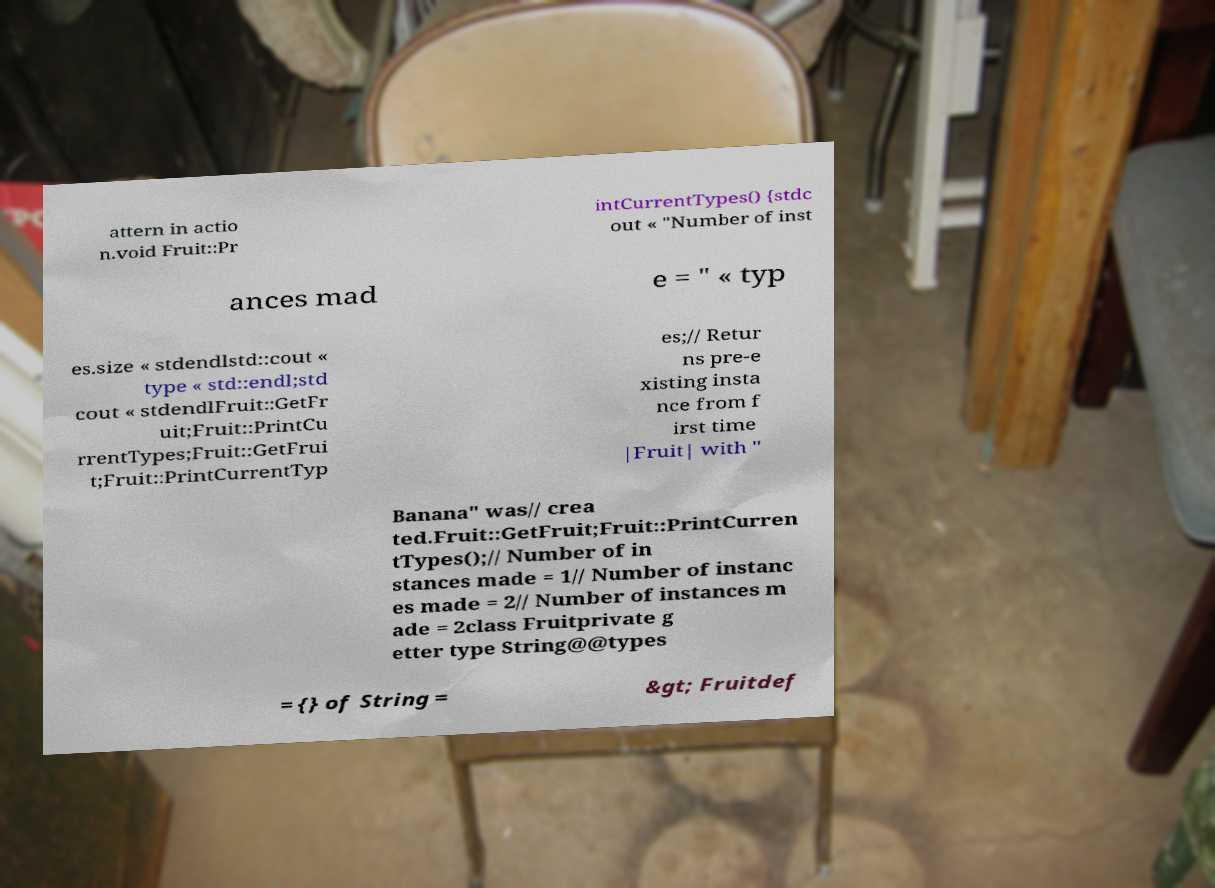There's text embedded in this image that I need extracted. Can you transcribe it verbatim? attern in actio n.void Fruit::Pr intCurrentTypes() {stdc out « "Number of inst ances mad e = " « typ es.size « stdendlstd::cout « type « std::endl;std cout « stdendlFruit::GetFr uit;Fruit::PrintCu rrentTypes;Fruit::GetFrui t;Fruit::PrintCurrentTyp es;// Retur ns pre-e xisting insta nce from f irst time |Fruit| with " Banana" was// crea ted.Fruit::GetFruit;Fruit::PrintCurren tTypes();// Number of in stances made = 1// Number of instanc es made = 2// Number of instances m ade = 2class Fruitprivate g etter type String@@types = {} of String = &gt; Fruitdef 